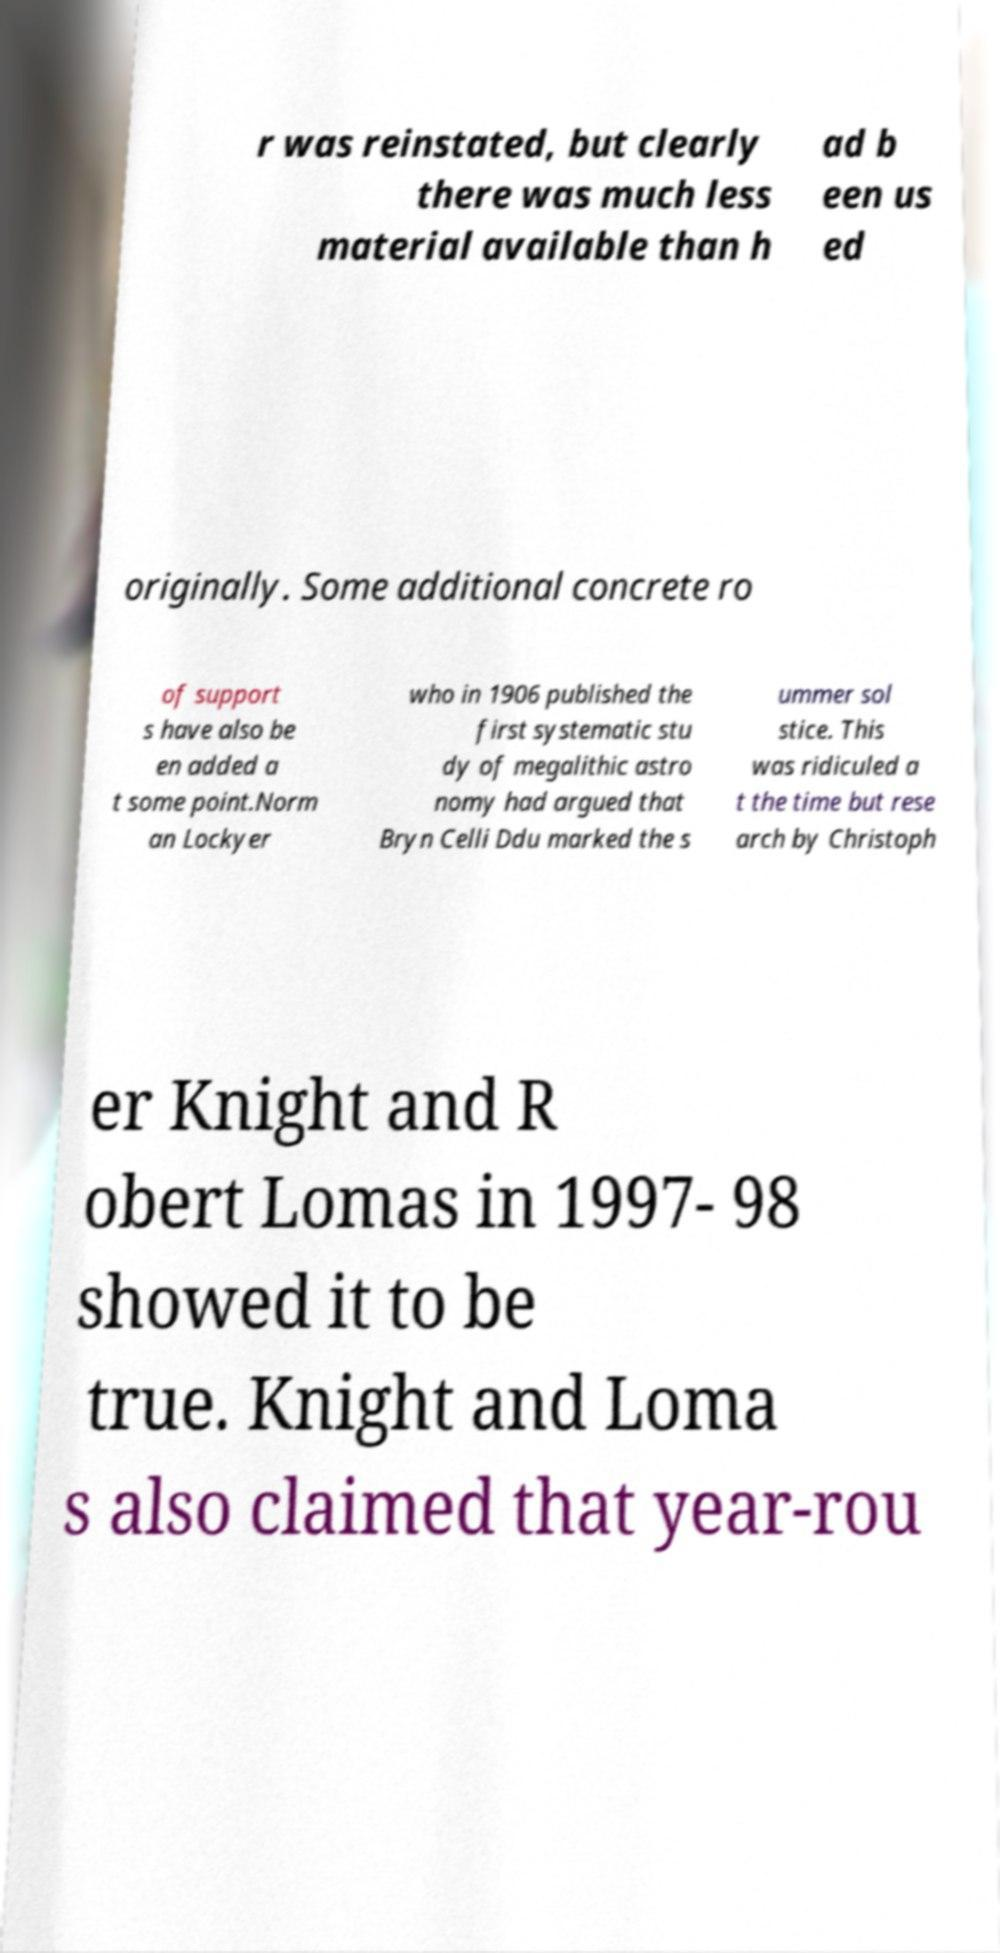Could you extract and type out the text from this image? r was reinstated, but clearly there was much less material available than h ad b een us ed originally. Some additional concrete ro of support s have also be en added a t some point.Norm an Lockyer who in 1906 published the first systematic stu dy of megalithic astro nomy had argued that Bryn Celli Ddu marked the s ummer sol stice. This was ridiculed a t the time but rese arch by Christoph er Knight and R obert Lomas in 1997- 98 showed it to be true. Knight and Loma s also claimed that year-rou 